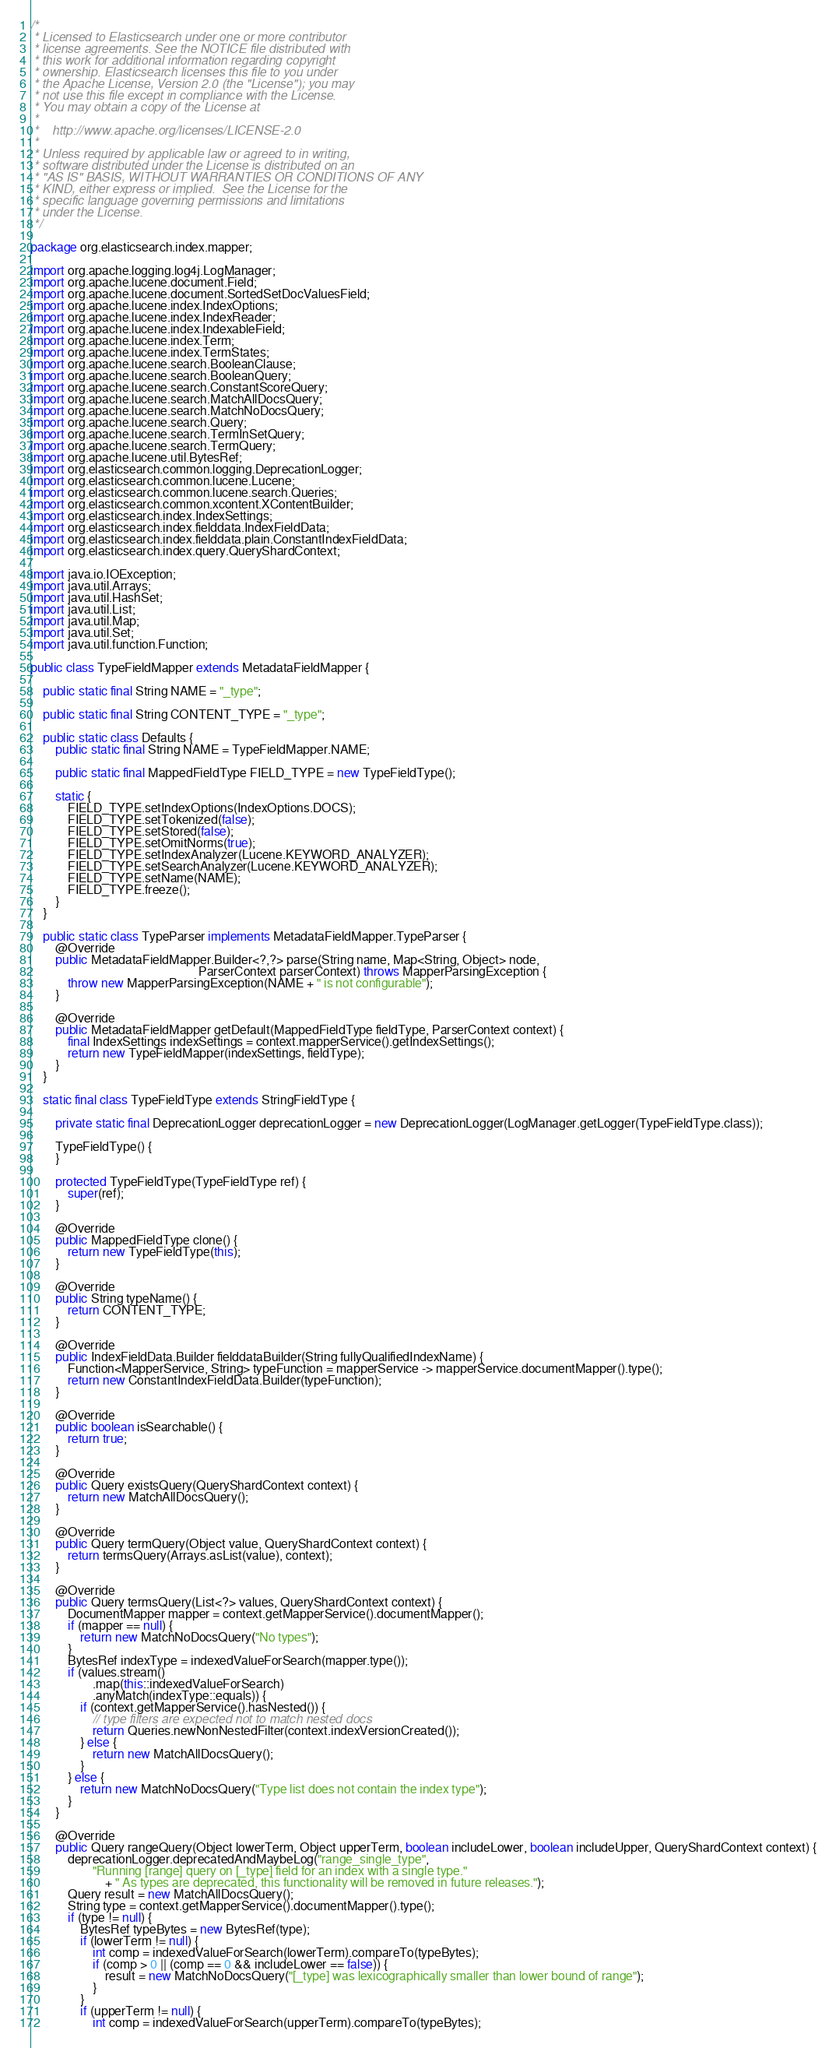<code> <loc_0><loc_0><loc_500><loc_500><_Java_>/*
 * Licensed to Elasticsearch under one or more contributor
 * license agreements. See the NOTICE file distributed with
 * this work for additional information regarding copyright
 * ownership. Elasticsearch licenses this file to you under
 * the Apache License, Version 2.0 (the "License"); you may
 * not use this file except in compliance with the License.
 * You may obtain a copy of the License at
 *
 *    http://www.apache.org/licenses/LICENSE-2.0
 *
 * Unless required by applicable law or agreed to in writing,
 * software distributed under the License is distributed on an
 * "AS IS" BASIS, WITHOUT WARRANTIES OR CONDITIONS OF ANY
 * KIND, either express or implied.  See the License for the
 * specific language governing permissions and limitations
 * under the License.
 */

package org.elasticsearch.index.mapper;

import org.apache.logging.log4j.LogManager;
import org.apache.lucene.document.Field;
import org.apache.lucene.document.SortedSetDocValuesField;
import org.apache.lucene.index.IndexOptions;
import org.apache.lucene.index.IndexReader;
import org.apache.lucene.index.IndexableField;
import org.apache.lucene.index.Term;
import org.apache.lucene.index.TermStates;
import org.apache.lucene.search.BooleanClause;
import org.apache.lucene.search.BooleanQuery;
import org.apache.lucene.search.ConstantScoreQuery;
import org.apache.lucene.search.MatchAllDocsQuery;
import org.apache.lucene.search.MatchNoDocsQuery;
import org.apache.lucene.search.Query;
import org.apache.lucene.search.TermInSetQuery;
import org.apache.lucene.search.TermQuery;
import org.apache.lucene.util.BytesRef;
import org.elasticsearch.common.logging.DeprecationLogger;
import org.elasticsearch.common.lucene.Lucene;
import org.elasticsearch.common.lucene.search.Queries;
import org.elasticsearch.common.xcontent.XContentBuilder;
import org.elasticsearch.index.IndexSettings;
import org.elasticsearch.index.fielddata.IndexFieldData;
import org.elasticsearch.index.fielddata.plain.ConstantIndexFieldData;
import org.elasticsearch.index.query.QueryShardContext;

import java.io.IOException;
import java.util.Arrays;
import java.util.HashSet;
import java.util.List;
import java.util.Map;
import java.util.Set;
import java.util.function.Function;

public class TypeFieldMapper extends MetadataFieldMapper {

    public static final String NAME = "_type";

    public static final String CONTENT_TYPE = "_type";

    public static class Defaults {
        public static final String NAME = TypeFieldMapper.NAME;

        public static final MappedFieldType FIELD_TYPE = new TypeFieldType();

        static {
            FIELD_TYPE.setIndexOptions(IndexOptions.DOCS);
            FIELD_TYPE.setTokenized(false);
            FIELD_TYPE.setStored(false);
            FIELD_TYPE.setOmitNorms(true);
            FIELD_TYPE.setIndexAnalyzer(Lucene.KEYWORD_ANALYZER);
            FIELD_TYPE.setSearchAnalyzer(Lucene.KEYWORD_ANALYZER);
            FIELD_TYPE.setName(NAME);
            FIELD_TYPE.freeze();
        }
    }

    public static class TypeParser implements MetadataFieldMapper.TypeParser {
        @Override
        public MetadataFieldMapper.Builder<?,?> parse(String name, Map<String, Object> node,
                                                      ParserContext parserContext) throws MapperParsingException {
            throw new MapperParsingException(NAME + " is not configurable");
        }

        @Override
        public MetadataFieldMapper getDefault(MappedFieldType fieldType, ParserContext context) {
            final IndexSettings indexSettings = context.mapperService().getIndexSettings();
            return new TypeFieldMapper(indexSettings, fieldType);
        }
    }

    static final class TypeFieldType extends StringFieldType {

        private static final DeprecationLogger deprecationLogger = new DeprecationLogger(LogManager.getLogger(TypeFieldType.class));

        TypeFieldType() {
        }

        protected TypeFieldType(TypeFieldType ref) {
            super(ref);
        }

        @Override
        public MappedFieldType clone() {
            return new TypeFieldType(this);
        }

        @Override
        public String typeName() {
            return CONTENT_TYPE;
        }

        @Override
        public IndexFieldData.Builder fielddataBuilder(String fullyQualifiedIndexName) {
            Function<MapperService, String> typeFunction = mapperService -> mapperService.documentMapper().type();
            return new ConstantIndexFieldData.Builder(typeFunction);
        }

        @Override
        public boolean isSearchable() {
            return true;
        }

        @Override
        public Query existsQuery(QueryShardContext context) {
            return new MatchAllDocsQuery();
        }

        @Override
        public Query termQuery(Object value, QueryShardContext context) {
            return termsQuery(Arrays.asList(value), context);
        }

        @Override
        public Query termsQuery(List<?> values, QueryShardContext context) {
            DocumentMapper mapper = context.getMapperService().documentMapper();
            if (mapper == null) {
                return new MatchNoDocsQuery("No types");
            }
            BytesRef indexType = indexedValueForSearch(mapper.type());
            if (values.stream()
                    .map(this::indexedValueForSearch)
                    .anyMatch(indexType::equals)) {
                if (context.getMapperService().hasNested()) {
                    // type filters are expected not to match nested docs
                    return Queries.newNonNestedFilter(context.indexVersionCreated());
                } else {
                    return new MatchAllDocsQuery();
                }
            } else {
                return new MatchNoDocsQuery("Type list does not contain the index type");
            }
        }

        @Override
        public Query rangeQuery(Object lowerTerm, Object upperTerm, boolean includeLower, boolean includeUpper, QueryShardContext context) {
            deprecationLogger.deprecatedAndMaybeLog("range_single_type",
                    "Running [range] query on [_type] field for an index with a single type."
                        + " As types are deprecated, this functionality will be removed in future releases.");
            Query result = new MatchAllDocsQuery();
            String type = context.getMapperService().documentMapper().type();
            if (type != null) {
                BytesRef typeBytes = new BytesRef(type);
                if (lowerTerm != null) {
                    int comp = indexedValueForSearch(lowerTerm).compareTo(typeBytes);
                    if (comp > 0 || (comp == 0 && includeLower == false)) {
                        result = new MatchNoDocsQuery("[_type] was lexicographically smaller than lower bound of range");
                    }
                }
                if (upperTerm != null) {
                    int comp = indexedValueForSearch(upperTerm).compareTo(typeBytes);</code> 